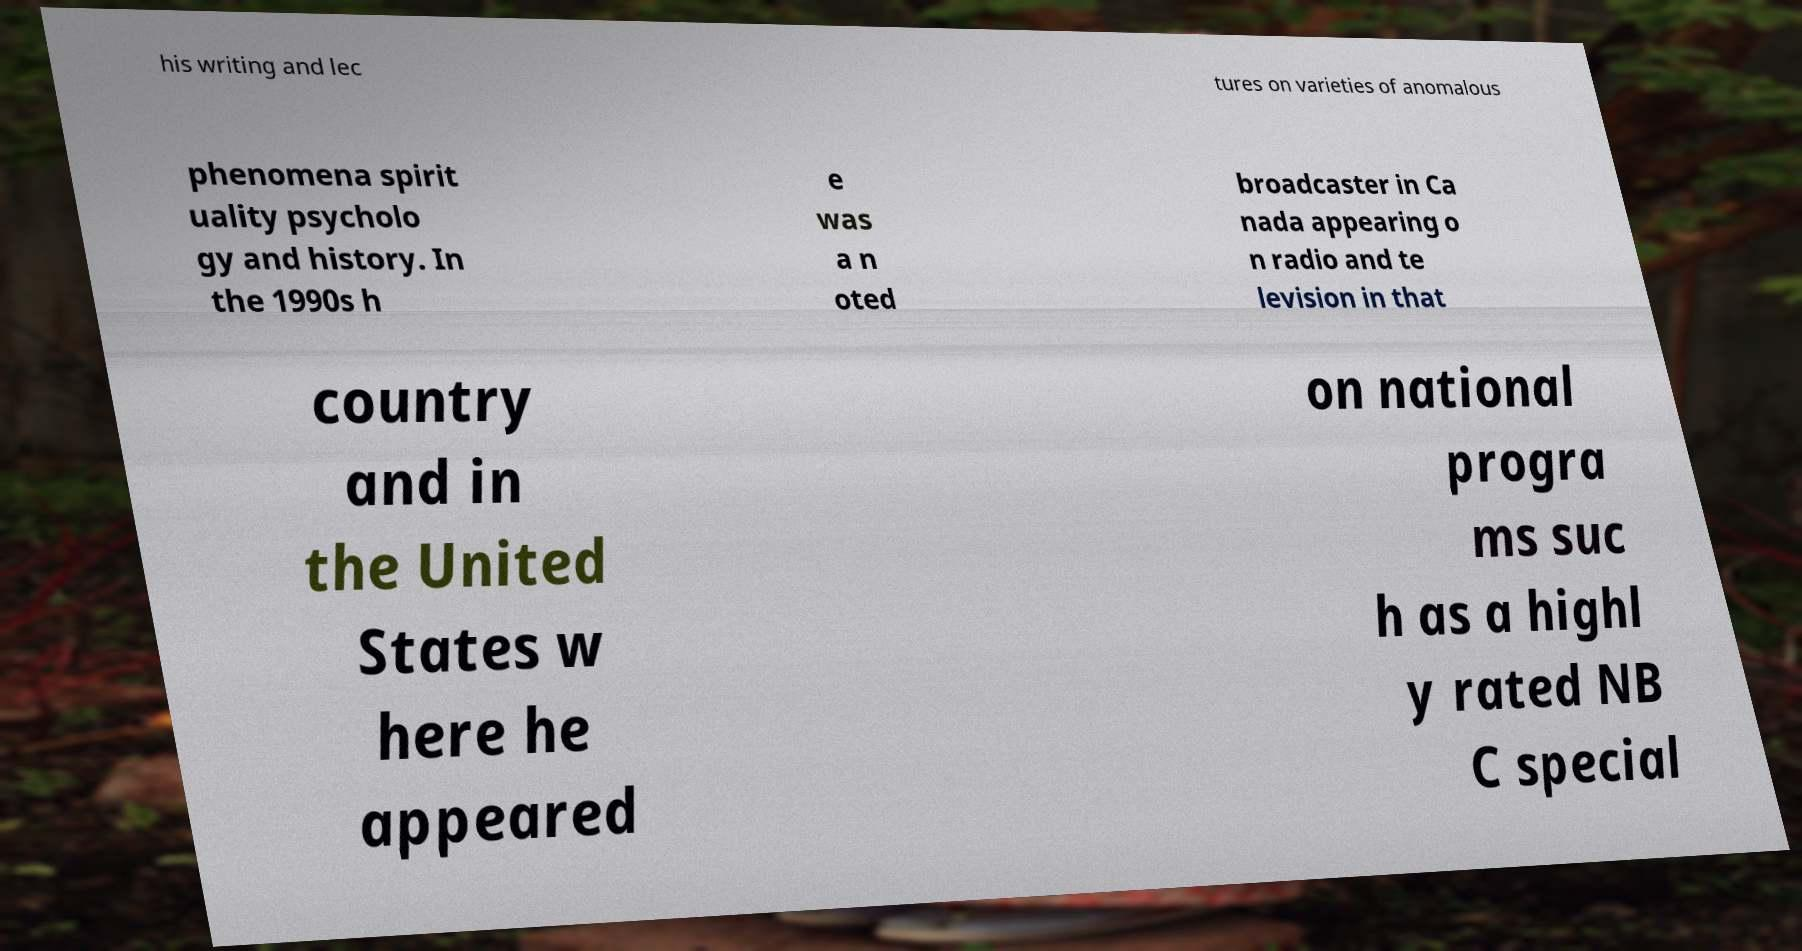Please identify and transcribe the text found in this image. his writing and lec tures on varieties of anomalous phenomena spirit uality psycholo gy and history. In the 1990s h e was a n oted broadcaster in Ca nada appearing o n radio and te levision in that country and in the United States w here he appeared on national progra ms suc h as a highl y rated NB C special 